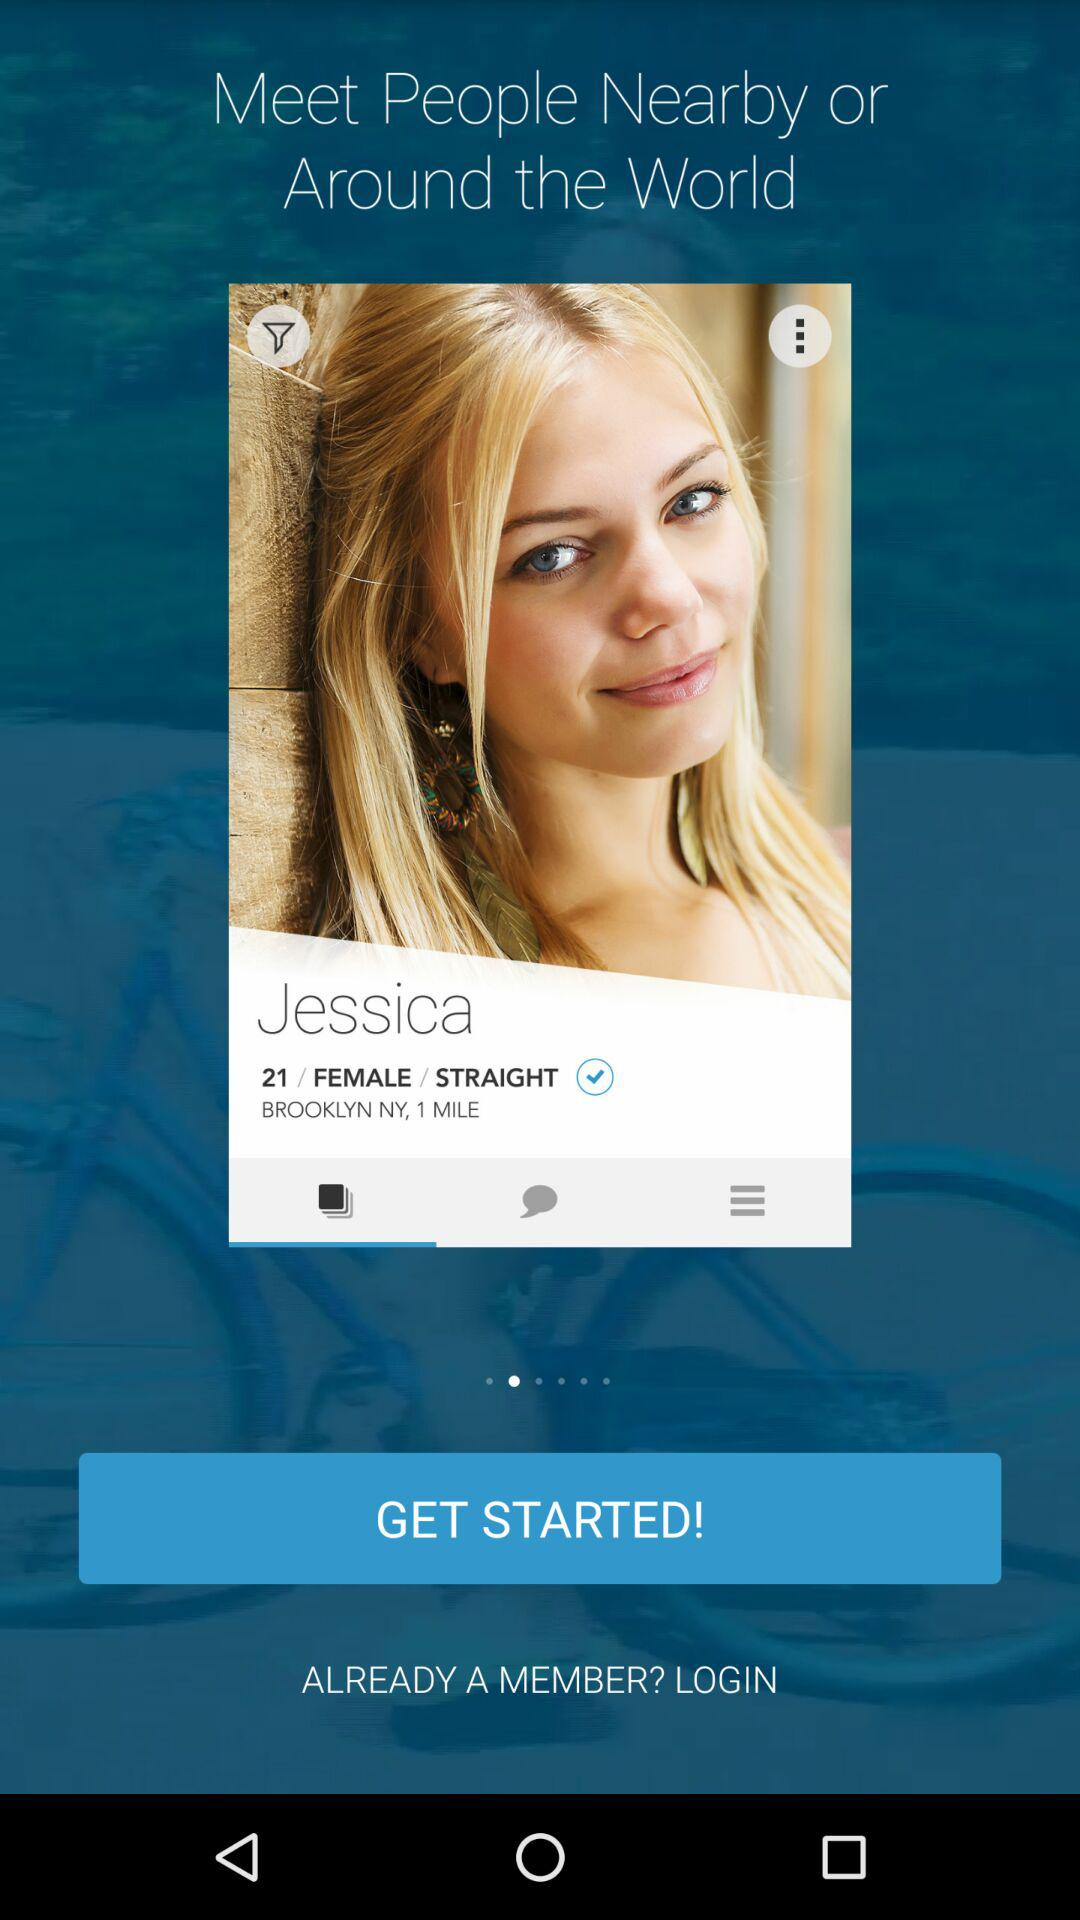What is the mentioned age? The mentioned age is 21. 